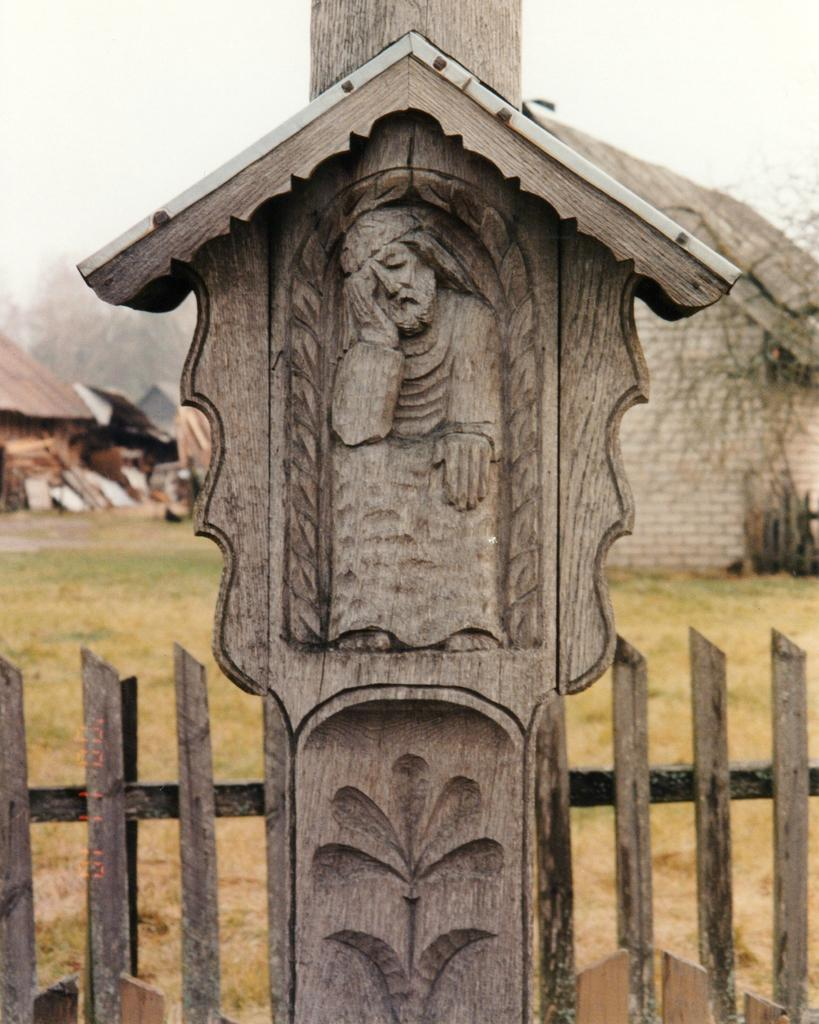What is the main subject in the center of the image? There is a carving on wood in the center of the image. What can be seen at the bottom of the image? There is a fence at the bottom of the image. What structures are visible in the background of the image? There are sheds in the background of the image. What part of the natural environment is visible in the image? The sky is visible in the background of the image. What type of glove is being used to ask a question in the image? There is no glove or question being asked in the image. What direction is the carving facing in the image? The carving on wood does not have a specific direction it is facing; it is a stationary object in the image. 